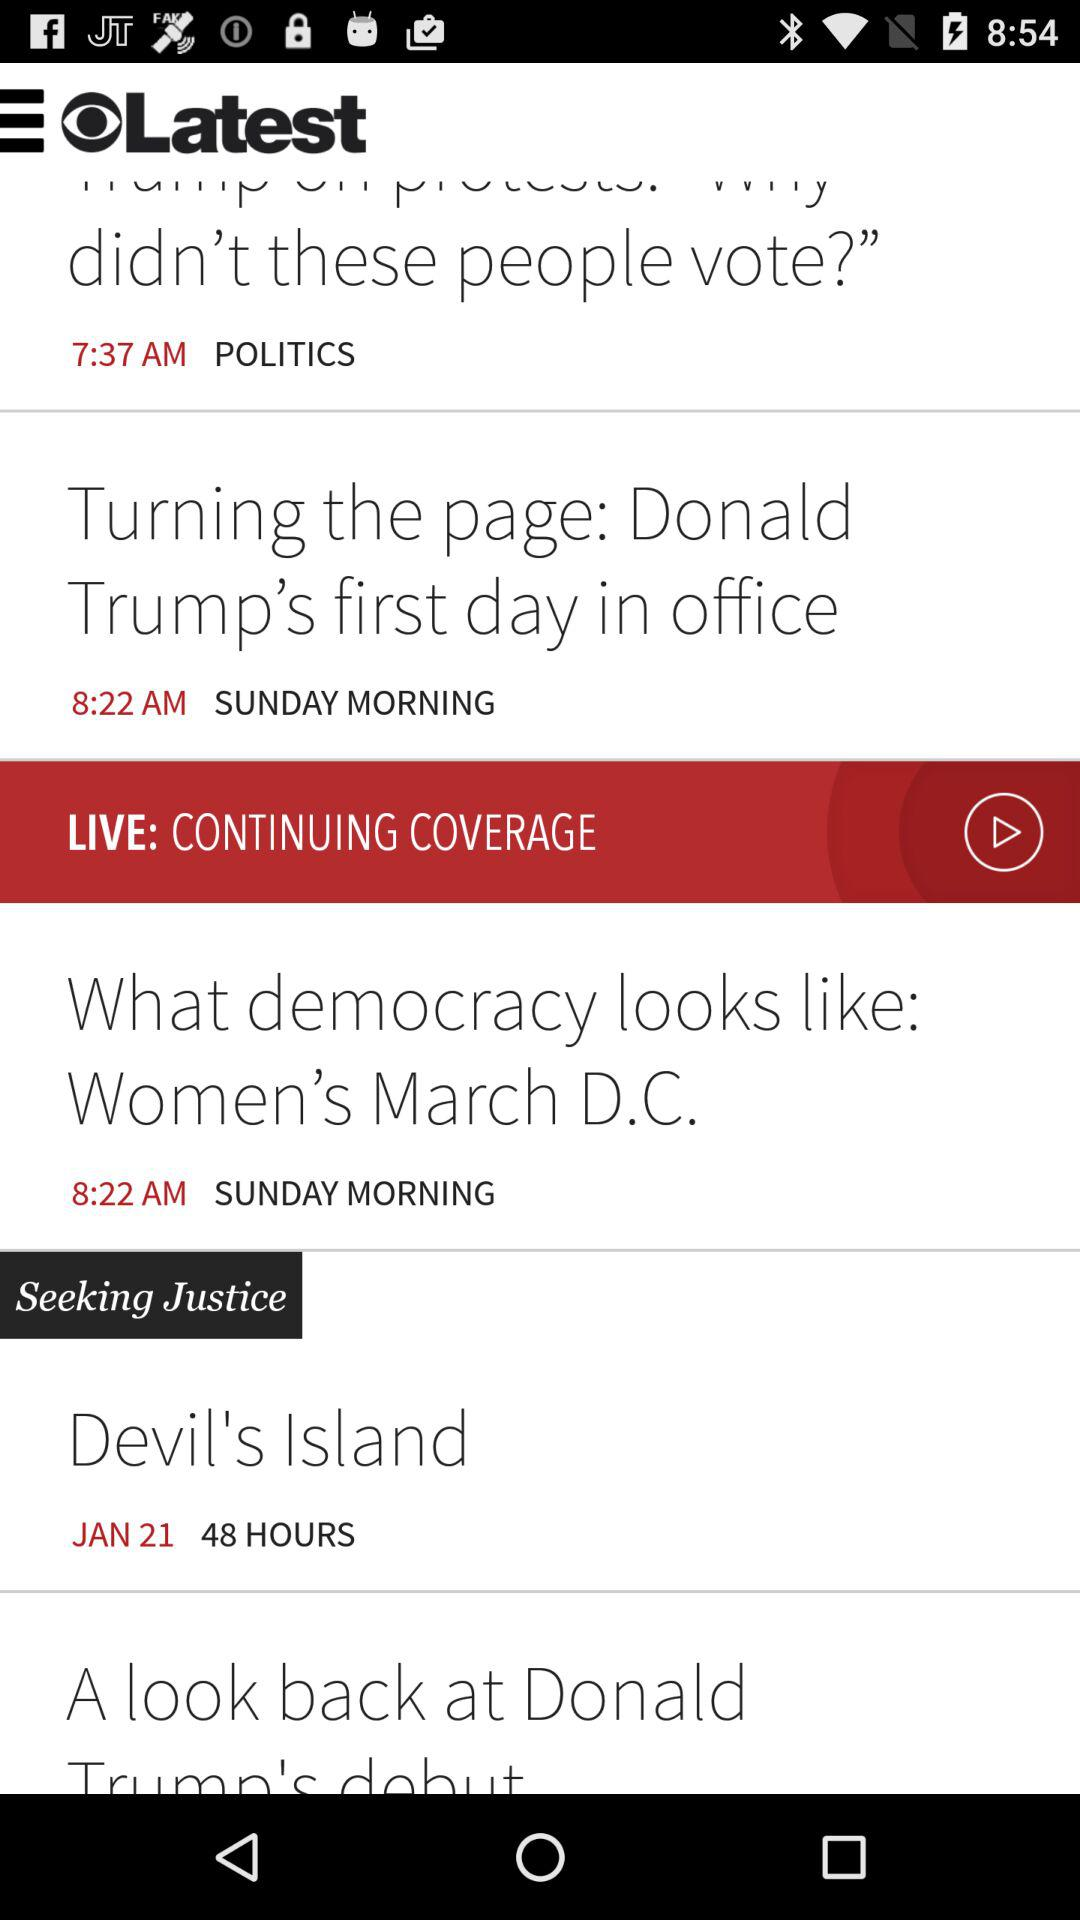How many items have the text 'Donald Trump'?
Answer the question using a single word or phrase. 2 